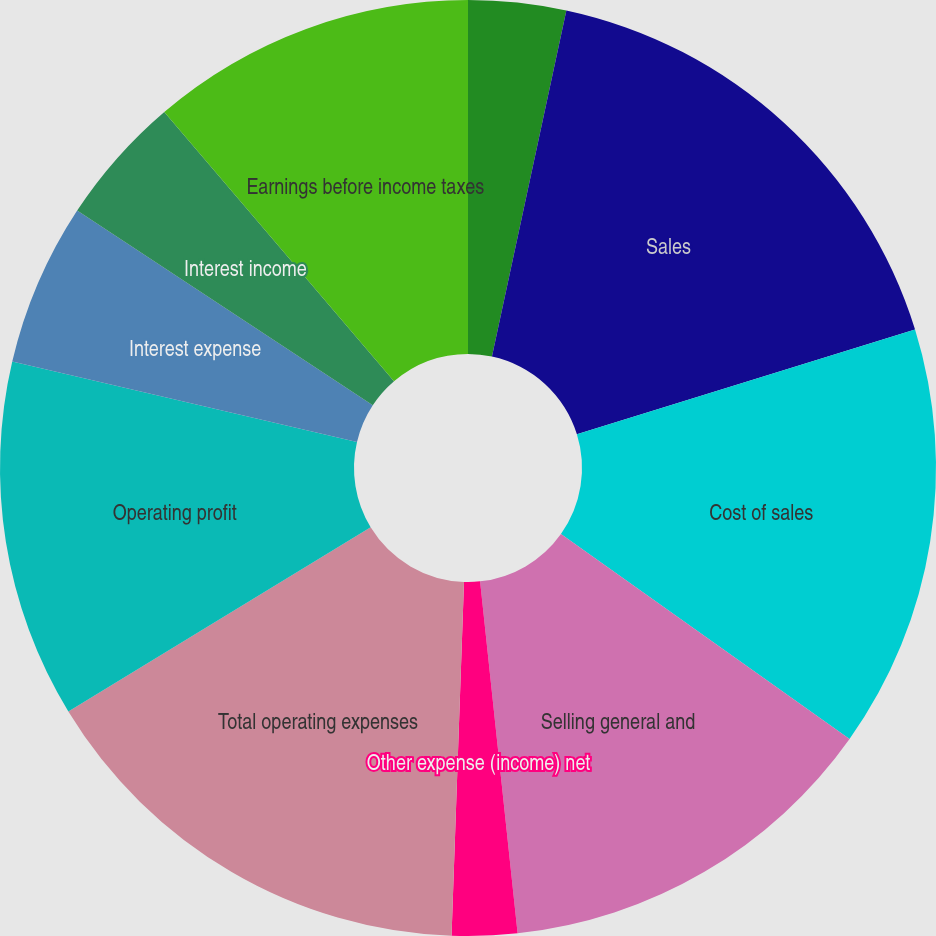Convert chart. <chart><loc_0><loc_0><loc_500><loc_500><pie_chart><fcel>Year Ended December 31 (in<fcel>Sales<fcel>Cost of sales<fcel>Selling general and<fcel>Other expense (income) net<fcel>Total operating expenses<fcel>Operating profit<fcel>Interest expense<fcel>Interest income<fcel>Earnings before income taxes<nl><fcel>3.37%<fcel>16.85%<fcel>14.61%<fcel>13.48%<fcel>2.25%<fcel>15.73%<fcel>12.36%<fcel>5.62%<fcel>4.49%<fcel>11.24%<nl></chart> 